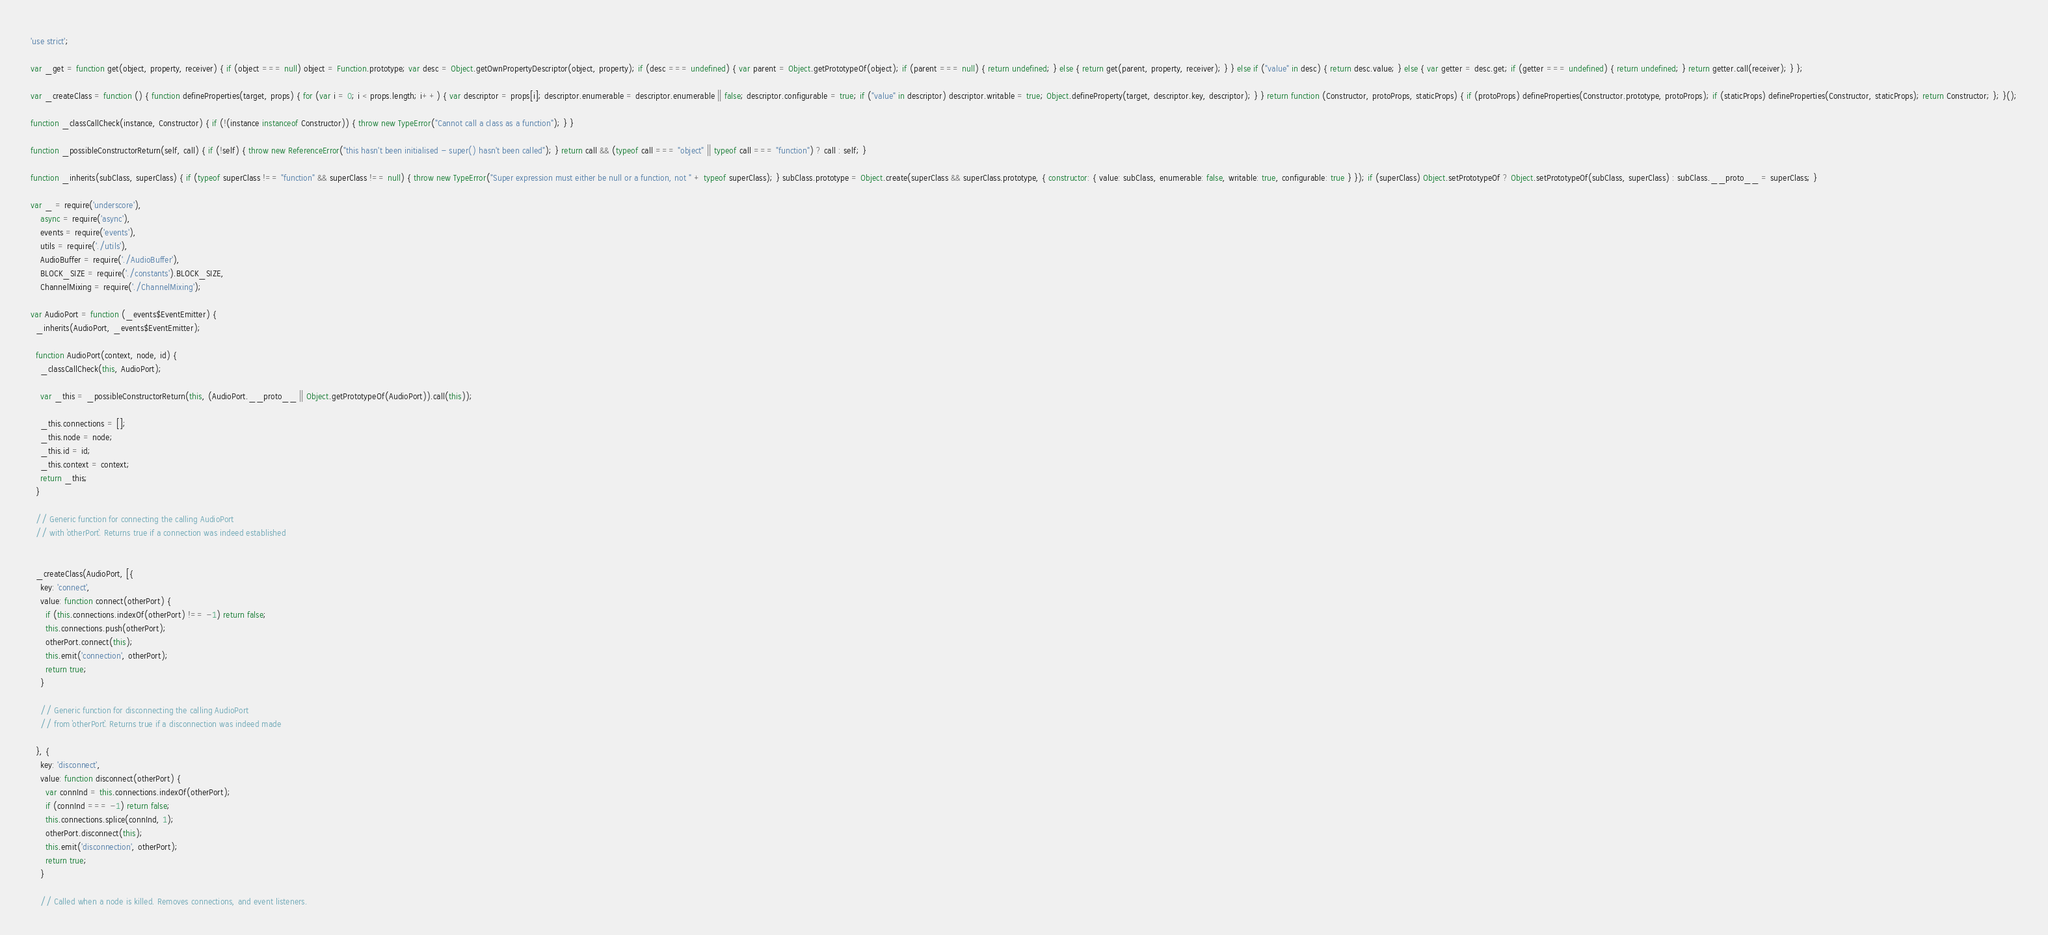<code> <loc_0><loc_0><loc_500><loc_500><_JavaScript_>'use strict';

var _get = function get(object, property, receiver) { if (object === null) object = Function.prototype; var desc = Object.getOwnPropertyDescriptor(object, property); if (desc === undefined) { var parent = Object.getPrototypeOf(object); if (parent === null) { return undefined; } else { return get(parent, property, receiver); } } else if ("value" in desc) { return desc.value; } else { var getter = desc.get; if (getter === undefined) { return undefined; } return getter.call(receiver); } };

var _createClass = function () { function defineProperties(target, props) { for (var i = 0; i < props.length; i++) { var descriptor = props[i]; descriptor.enumerable = descriptor.enumerable || false; descriptor.configurable = true; if ("value" in descriptor) descriptor.writable = true; Object.defineProperty(target, descriptor.key, descriptor); } } return function (Constructor, protoProps, staticProps) { if (protoProps) defineProperties(Constructor.prototype, protoProps); if (staticProps) defineProperties(Constructor, staticProps); return Constructor; }; }();

function _classCallCheck(instance, Constructor) { if (!(instance instanceof Constructor)) { throw new TypeError("Cannot call a class as a function"); } }

function _possibleConstructorReturn(self, call) { if (!self) { throw new ReferenceError("this hasn't been initialised - super() hasn't been called"); } return call && (typeof call === "object" || typeof call === "function") ? call : self; }

function _inherits(subClass, superClass) { if (typeof superClass !== "function" && superClass !== null) { throw new TypeError("Super expression must either be null or a function, not " + typeof superClass); } subClass.prototype = Object.create(superClass && superClass.prototype, { constructor: { value: subClass, enumerable: false, writable: true, configurable: true } }); if (superClass) Object.setPrototypeOf ? Object.setPrototypeOf(subClass, superClass) : subClass.__proto__ = superClass; }

var _ = require('underscore'),
    async = require('async'),
    events = require('events'),
    utils = require('./utils'),
    AudioBuffer = require('./AudioBuffer'),
    BLOCK_SIZE = require('./constants').BLOCK_SIZE,
    ChannelMixing = require('./ChannelMixing');

var AudioPort = function (_events$EventEmitter) {
  _inherits(AudioPort, _events$EventEmitter);

  function AudioPort(context, node, id) {
    _classCallCheck(this, AudioPort);

    var _this = _possibleConstructorReturn(this, (AudioPort.__proto__ || Object.getPrototypeOf(AudioPort)).call(this));

    _this.connections = [];
    _this.node = node;
    _this.id = id;
    _this.context = context;
    return _this;
  }

  // Generic function for connecting the calling AudioPort
  // with `otherPort`. Returns true if a connection was indeed established


  _createClass(AudioPort, [{
    key: 'connect',
    value: function connect(otherPort) {
      if (this.connections.indexOf(otherPort) !== -1) return false;
      this.connections.push(otherPort);
      otherPort.connect(this);
      this.emit('connection', otherPort);
      return true;
    }

    // Generic function for disconnecting the calling AudioPort
    // from `otherPort`. Returns true if a disconnection was indeed made

  }, {
    key: 'disconnect',
    value: function disconnect(otherPort) {
      var connInd = this.connections.indexOf(otherPort);
      if (connInd === -1) return false;
      this.connections.splice(connInd, 1);
      otherPort.disconnect(this);
      this.emit('disconnection', otherPort);
      return true;
    }

    // Called when a node is killed. Removes connections, and event listeners.
</code> 